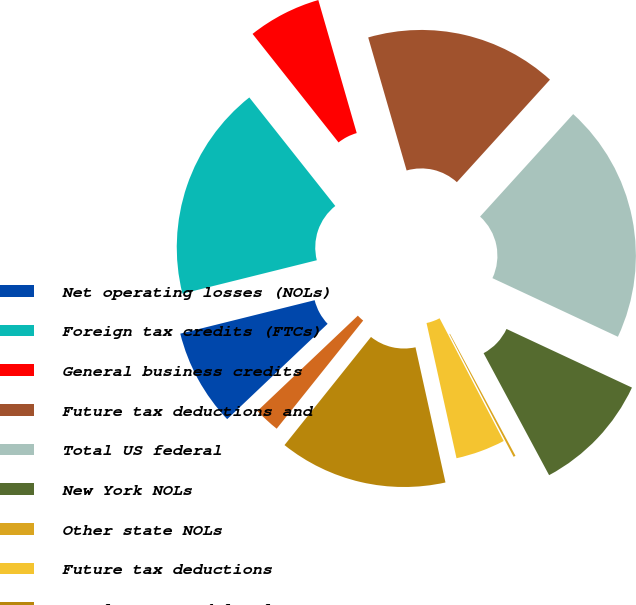Convert chart. <chart><loc_0><loc_0><loc_500><loc_500><pie_chart><fcel>Net operating losses (NOLs)<fcel>Foreign tax credits (FTCs)<fcel>General business credits<fcel>Future tax deductions and<fcel>Total US federal<fcel>New York NOLs<fcel>Other state NOLs<fcel>Future tax deductions<fcel>Total state and local<fcel>NOLs<nl><fcel>8.2%<fcel>18.22%<fcel>6.19%<fcel>16.21%<fcel>20.22%<fcel>10.2%<fcel>0.18%<fcel>4.19%<fcel>14.21%<fcel>2.18%<nl></chart> 